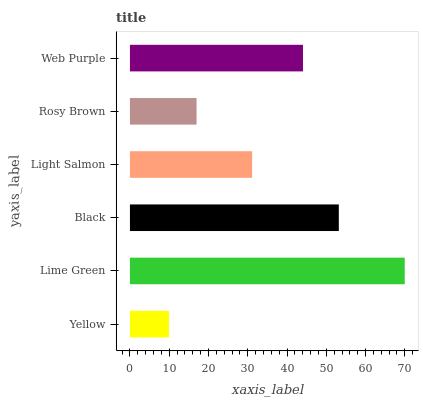Is Yellow the minimum?
Answer yes or no. Yes. Is Lime Green the maximum?
Answer yes or no. Yes. Is Black the minimum?
Answer yes or no. No. Is Black the maximum?
Answer yes or no. No. Is Lime Green greater than Black?
Answer yes or no. Yes. Is Black less than Lime Green?
Answer yes or no. Yes. Is Black greater than Lime Green?
Answer yes or no. No. Is Lime Green less than Black?
Answer yes or no. No. Is Web Purple the high median?
Answer yes or no. Yes. Is Light Salmon the low median?
Answer yes or no. Yes. Is Light Salmon the high median?
Answer yes or no. No. Is Black the low median?
Answer yes or no. No. 